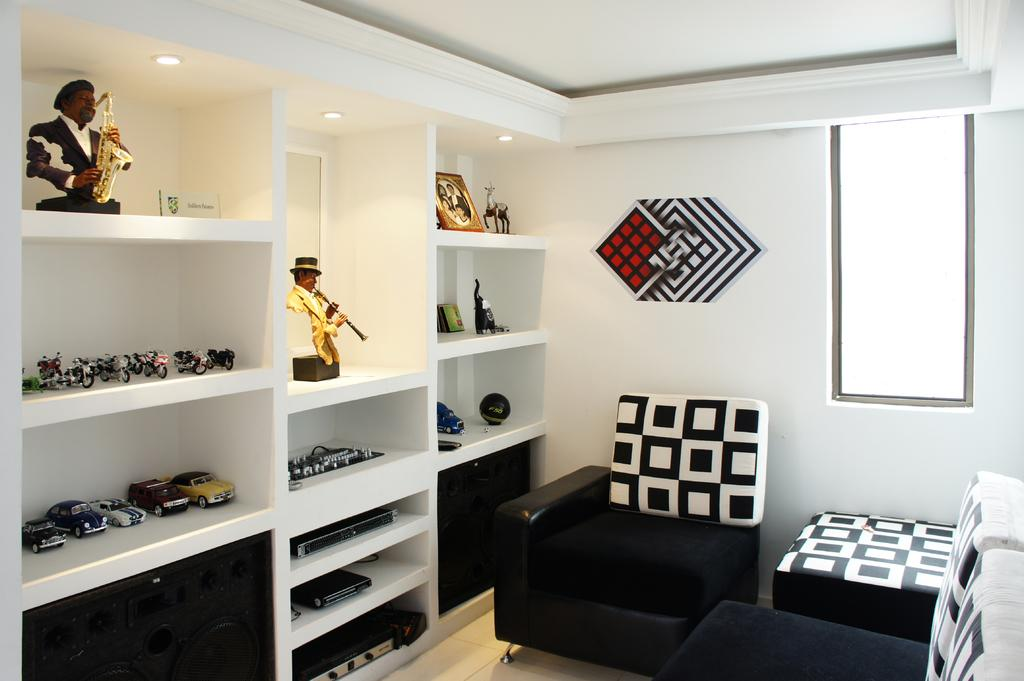What type of space is shown in the image? The image depicts the interior of a room. What type of furniture is present in the room? There are sofas in the room. What other items can be seen in the room? There are toys in the room. Can you describe any decorative elements in the room? There is a frame in the racks in the room. What type of feast is being prepared in the room? There is no indication of a feast being prepared in the room; the image only shows sofas, toys, and a frame in the racks. How many pets are visible in the room? There are no pets visible in the room; the image only shows sofas, toys, and a frame in the racks. 